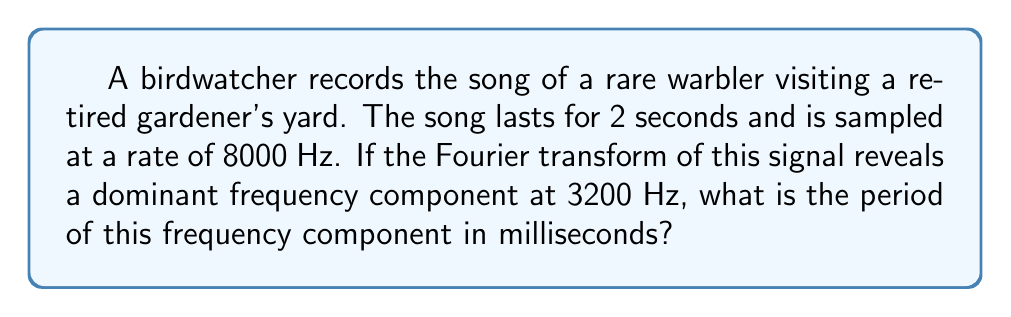Can you answer this question? Let's approach this step-by-step:

1) The Fourier transform has revealed a dominant frequency component at 3200 Hz.

2) The period of a signal is the inverse of its frequency. The relationship between frequency ($f$) and period ($T$) is given by:

   $$T = \frac{1}{f}$$

3) We need to substitute $f = 3200$ Hz into this equation:

   $$T = \frac{1}{3200} \text{ seconds}$$

4) To convert this to milliseconds, we multiply by 1000:

   $$T = \frac{1}{3200} \times 1000 \text{ milliseconds}$$

5) Simplifying:

   $$T = \frac{1000}{3200} \text{ milliseconds}$$

6) Reducing the fraction:

   $$T = \frac{5}{16} \text{ milliseconds}$$

7) As a decimal:

   $$T \approx 0.3125 \text{ milliseconds}$$
Answer: $\frac{5}{16}$ ms or approximately 0.3125 ms 